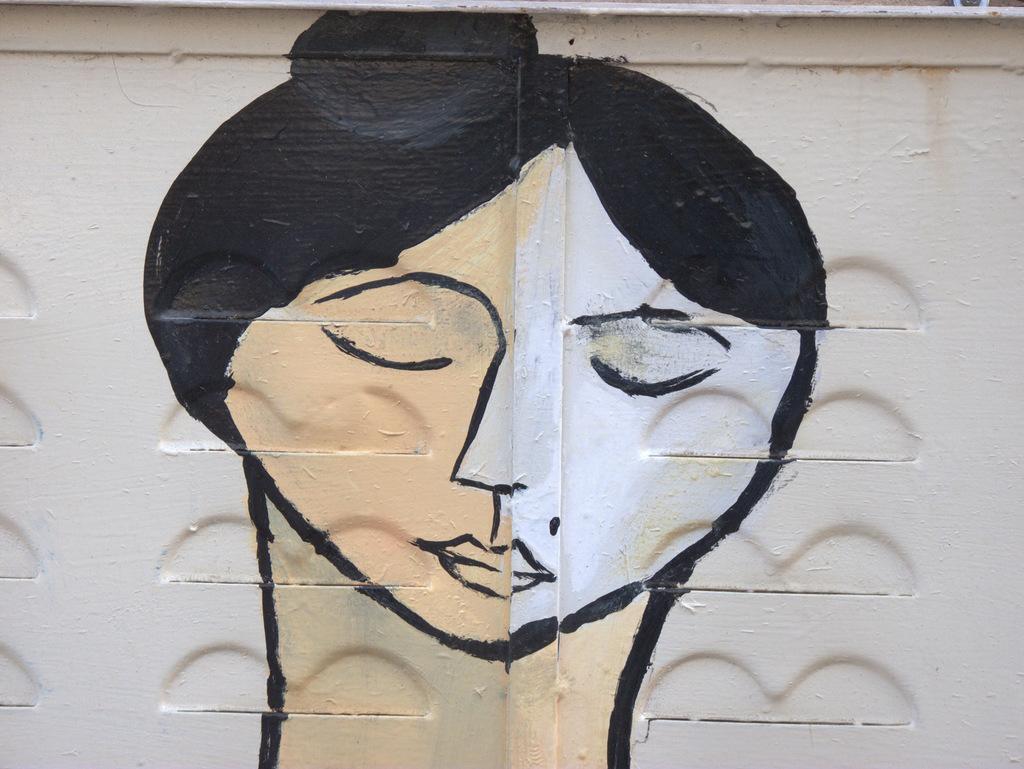Please provide a concise description of this image. In the image there is a painting of a woman on a wall. 